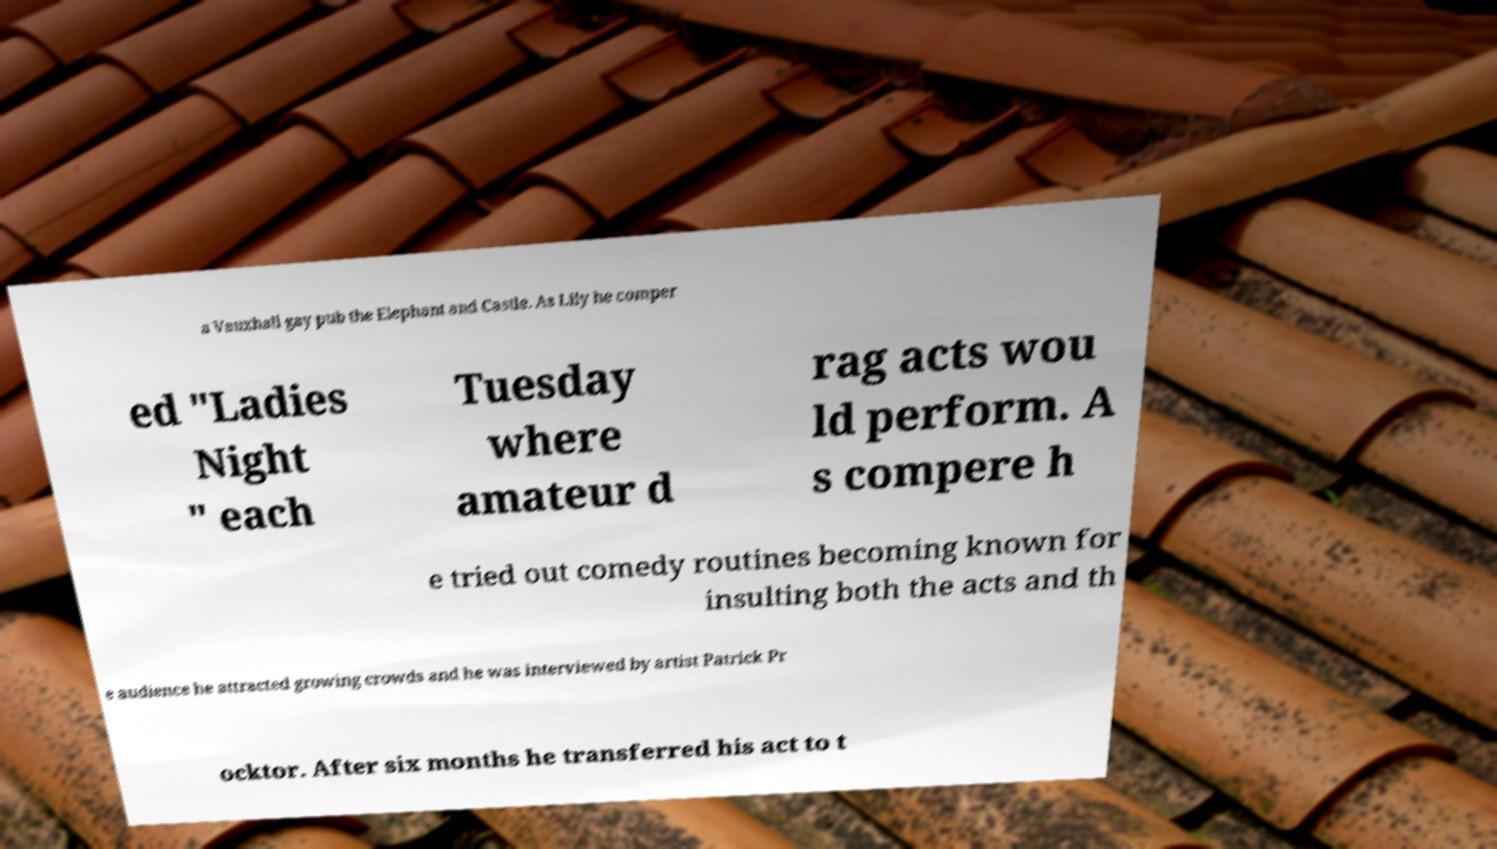There's text embedded in this image that I need extracted. Can you transcribe it verbatim? a Vauxhall gay pub the Elephant and Castle. As Lily he comper ed "Ladies Night " each Tuesday where amateur d rag acts wou ld perform. A s compere h e tried out comedy routines becoming known for insulting both the acts and th e audience he attracted growing crowds and he was interviewed by artist Patrick Pr ocktor. After six months he transferred his act to t 